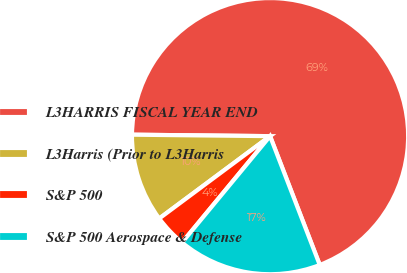Convert chart to OTSL. <chart><loc_0><loc_0><loc_500><loc_500><pie_chart><fcel>L3HARRIS FISCAL YEAR END<fcel>L3Harris (Prior to L3Harris<fcel>S&P 500<fcel>S&P 500 Aerospace & Defense<nl><fcel>68.97%<fcel>10.34%<fcel>3.83%<fcel>16.86%<nl></chart> 